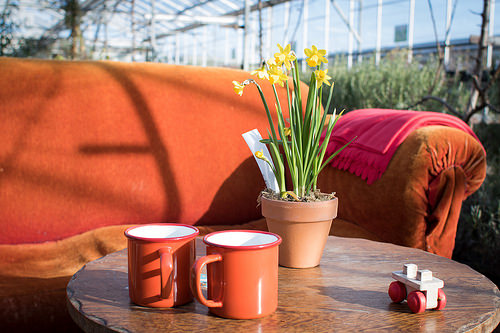<image>
Can you confirm if the cup is under the table? No. The cup is not positioned under the table. The vertical relationship between these objects is different. Where is the flowers in relation to the cup? Is it in the cup? No. The flowers is not contained within the cup. These objects have a different spatial relationship. 